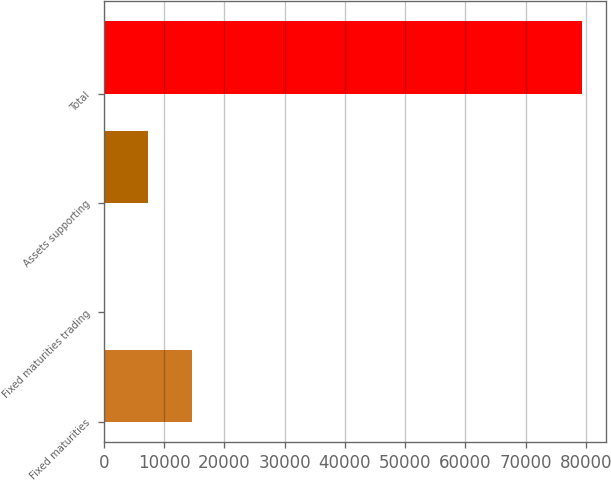Convert chart. <chart><loc_0><loc_0><loc_500><loc_500><bar_chart><fcel>Fixed maturities<fcel>Fixed maturities trading<fcel>Assets supporting<fcel>Total<nl><fcel>14723.4<fcel>22<fcel>7372.7<fcel>79302.7<nl></chart> 